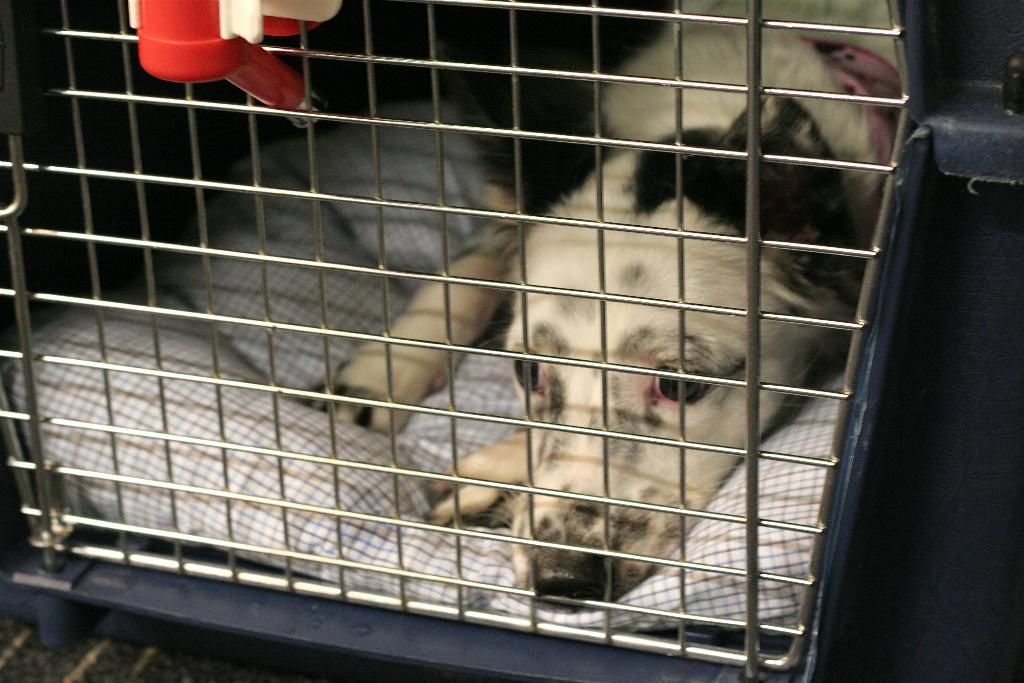What animal can be seen in the image? There is a dog in the image. What is the dog doing in the image? The dog is sleeping on a pillow. Is there any structure or object around the dog? Yes, there is a cage around the dog. What letters are visible on the dog's collar in the image? There is no collar visible on the dog in the image, and therefore no letters can be seen. 